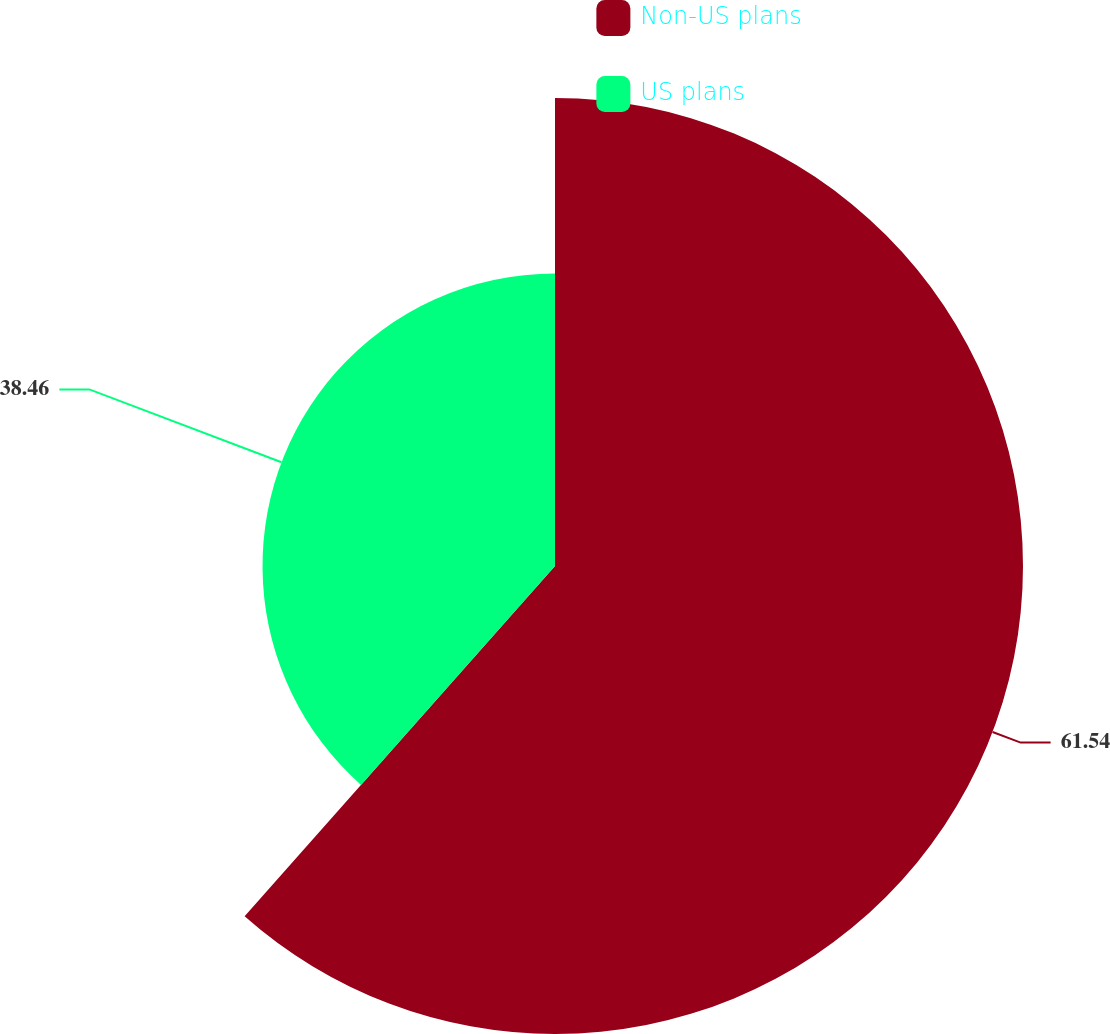Convert chart. <chart><loc_0><loc_0><loc_500><loc_500><pie_chart><fcel>Non-US plans<fcel>US plans<nl><fcel>61.54%<fcel>38.46%<nl></chart> 